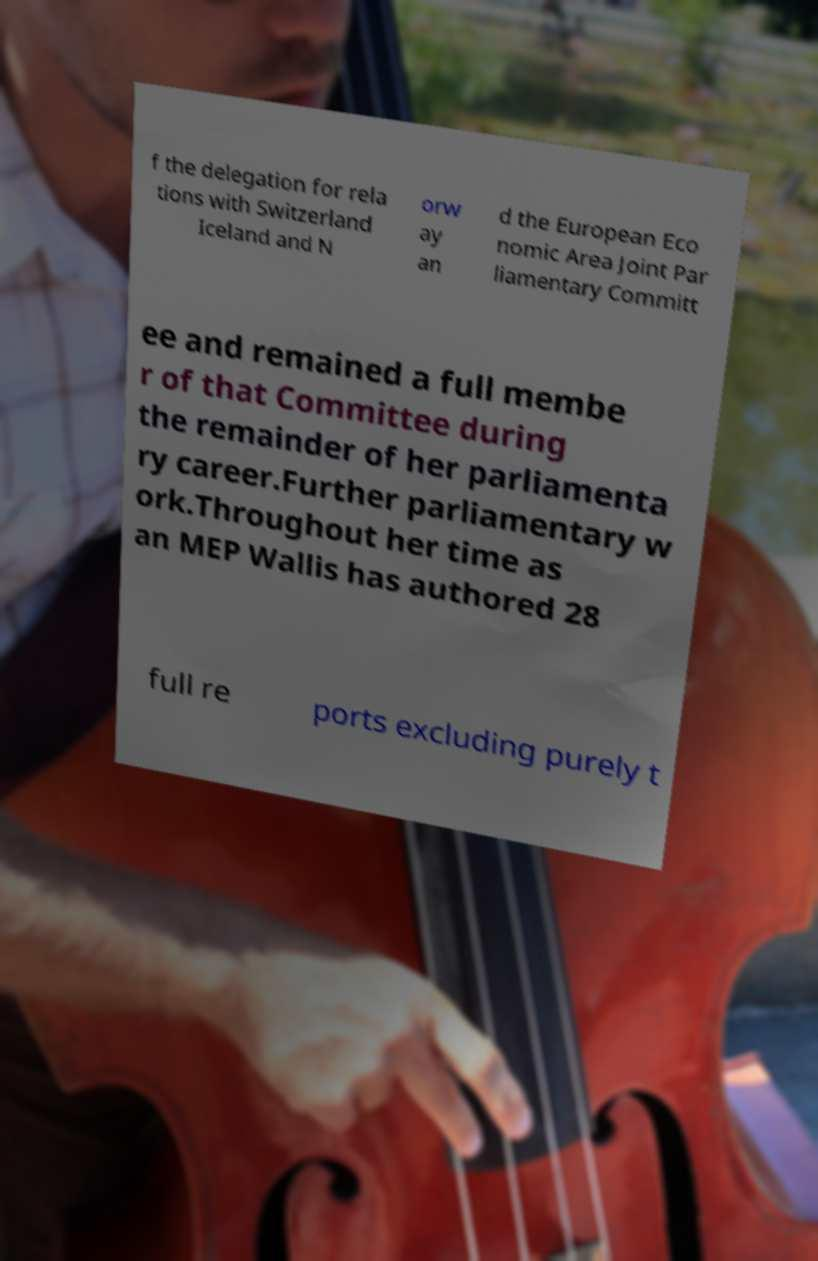Could you extract and type out the text from this image? f the delegation for rela tions with Switzerland Iceland and N orw ay an d the European Eco nomic Area Joint Par liamentary Committ ee and remained a full membe r of that Committee during the remainder of her parliamenta ry career.Further parliamentary w ork.Throughout her time as an MEP Wallis has authored 28 full re ports excluding purely t 